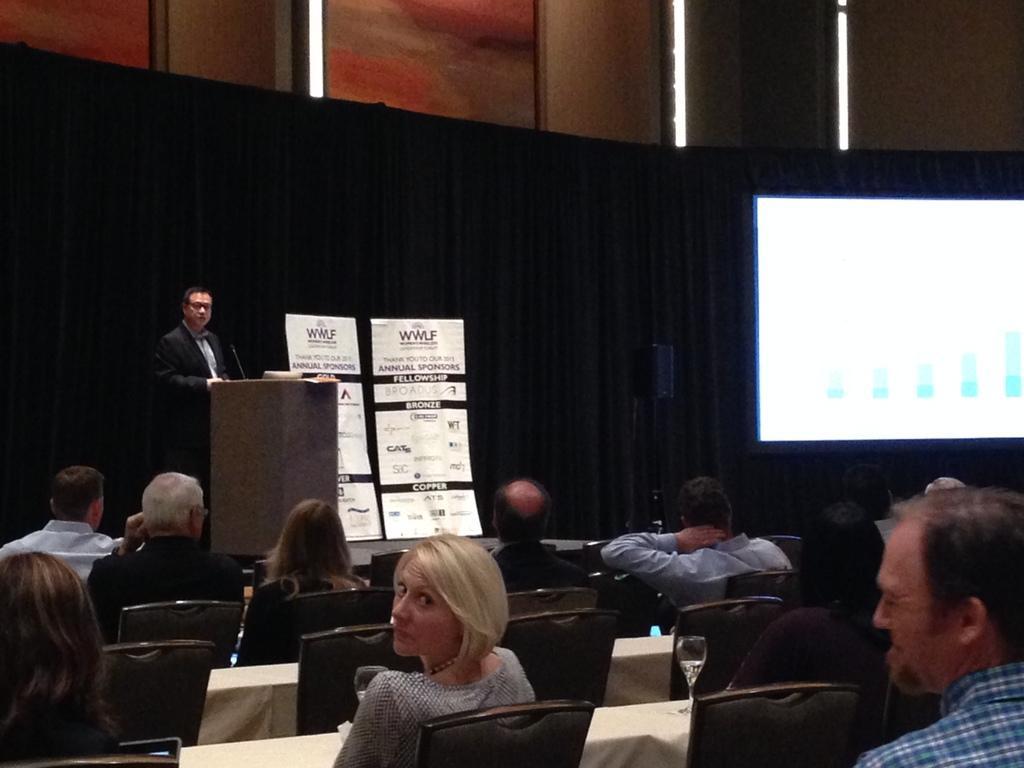Can you describe this image briefly? There are persons in different color dresses, sitting on chairs. In front of them, there are tables, on which there are some objects. In the background, there is a person in a suit, standing in front of a stand, on which there is a mic and other objects, beside him, there are two banners and a black color sheet, there is a screen arranged and there are lights attached to the wall. 